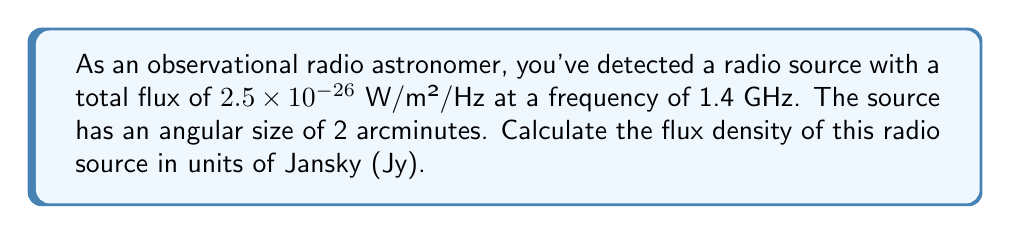Can you solve this math problem? To solve this problem, we'll follow these steps:

1) First, recall that 1 Jansky (Jy) is defined as:

   $$ 1 \text{ Jy} = 10^{-26} \text{ W/m²/Hz} $$

2) We're given the total flux in W/m²/Hz, so we need to convert this to Jy:

   $$ \text{Flux in Jy} = \frac{\text{Flux in W/m²/Hz}}{10^{-26}} $$

3) Substituting our given flux:

   $$ \text{Flux in Jy} = \frac{2.5 \times 10^{-26}}{10^{-26}} = 2.5 \text{ Jy} $$

4) Now, we need to calculate the flux density. Flux density is the flux per unit solid angle. The solid angle is given in steradians (sr).

5) To convert from arcminutes to steradians, we use:

   $$ \Omega = \left(\frac{\pi}{180 \times 60}\right)^2 \times (\text{angular size in arcminutes})^2 $$

6) Substituting our angular size of 2 arcminutes:

   $$ \Omega = \left(\frac{\pi}{180 \times 60}\right)^2 \times 2^2 = 3.046 \times 10^{-7} \text{ sr} $$

7) Now we can calculate the flux density:

   $$ \text{Flux Density} = \frac{\text{Flux}}{\text{Solid Angle}} = \frac{2.5 \text{ Jy}}{3.046 \times 10^{-7} \text{ sr}} $$

8) Simplifying:

   $$ \text{Flux Density} = 8.21 \times 10^6 \text{ Jy/sr} $$
Answer: $8.21 \times 10^6 \text{ Jy/sr}$ 